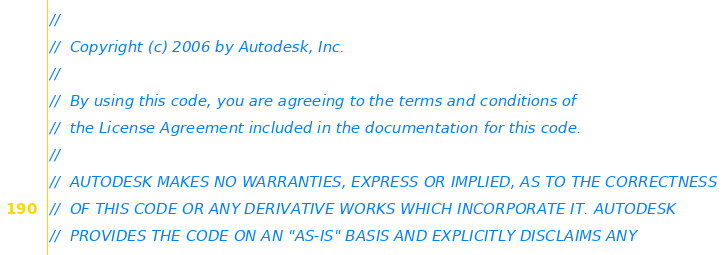<code> <loc_0><loc_0><loc_500><loc_500><_C_>//
//  Copyright (c) 2006 by Autodesk, Inc.
//
//  By using this code, you are agreeing to the terms and conditions of
//  the License Agreement included in the documentation for this code.
//
//  AUTODESK MAKES NO WARRANTIES, EXPRESS OR IMPLIED, AS TO THE CORRECTNESS
//  OF THIS CODE OR ANY DERIVATIVE WORKS WHICH INCORPORATE IT. AUTODESK
//  PROVIDES THE CODE ON AN "AS-IS" BASIS AND EXPLICITLY DISCLAIMS ANY</code> 